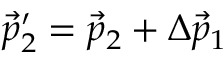<formula> <loc_0><loc_0><loc_500><loc_500>\vec { p } _ { 2 } ^ { \prime } = \vec { p } _ { 2 } + \Delta \vec { p } _ { 1 }</formula> 